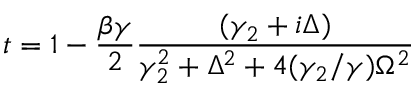Convert formula to latex. <formula><loc_0><loc_0><loc_500><loc_500>t = 1 - \frac { \beta \gamma } { 2 } \frac { ( \gamma _ { 2 } + i \Delta ) } { \gamma _ { 2 } ^ { 2 } + \Delta ^ { 2 } + 4 ( \gamma _ { 2 } / \gamma ) \Omega ^ { 2 } }</formula> 